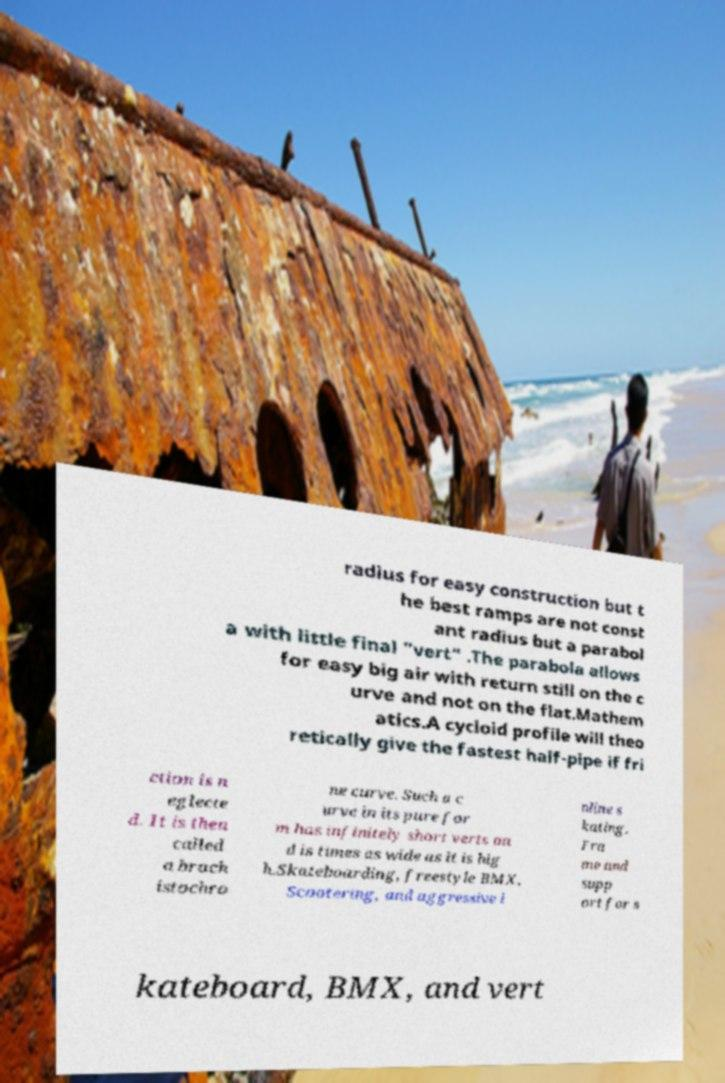There's text embedded in this image that I need extracted. Can you transcribe it verbatim? radius for easy construction but t he best ramps are not const ant radius but a parabol a with little final "vert" .The parabola allows for easy big air with return still on the c urve and not on the flat.Mathem atics.A cycloid profile will theo retically give the fastest half-pipe if fri ction is n eglecte d. It is then called a brach istochro ne curve. Such a c urve in its pure for m has infinitely short verts an d is times as wide as it is hig h.Skateboarding, freestyle BMX, Scootering, and aggressive i nline s kating. Fra me and supp ort for s kateboard, BMX, and vert 